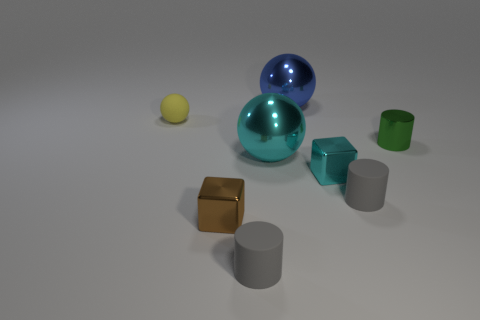Which objects in the image are reflective? The two spherical objects, one blue and the other teal, are reflective. Their surfaces are mirroring the environment and each other. 